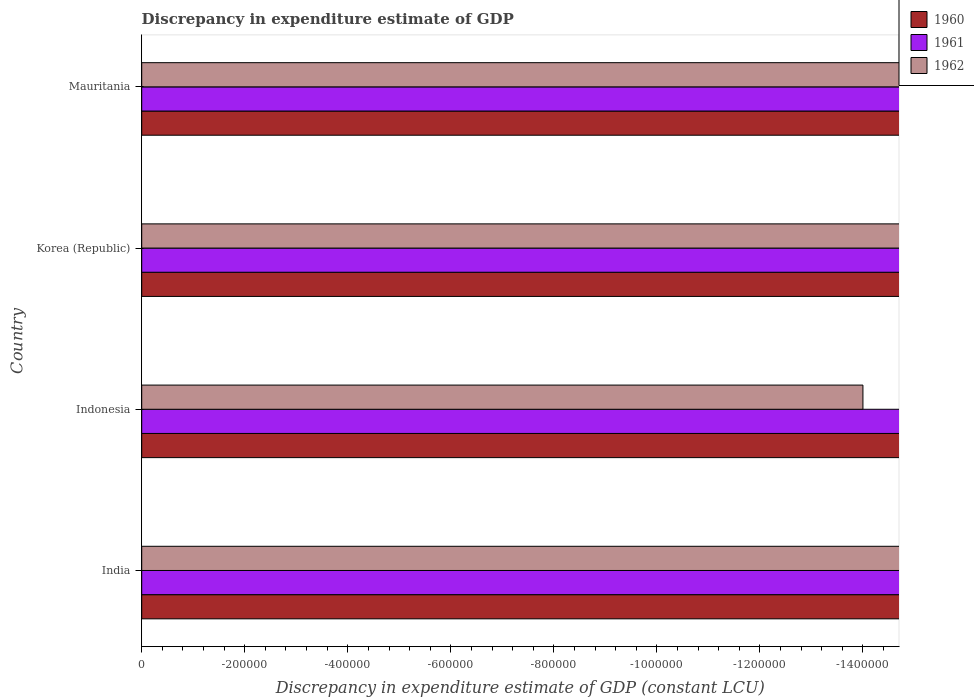Are the number of bars per tick equal to the number of legend labels?
Offer a very short reply. No. Are the number of bars on each tick of the Y-axis equal?
Provide a succinct answer. Yes. How many bars are there on the 3rd tick from the top?
Provide a succinct answer. 0. How many bars are there on the 3rd tick from the bottom?
Offer a terse response. 0. What is the label of the 4th group of bars from the top?
Provide a succinct answer. India. In how many cases, is the number of bars for a given country not equal to the number of legend labels?
Keep it short and to the point. 4. What is the discrepancy in expenditure estimate of GDP in 1960 in Indonesia?
Your answer should be compact. 0. What is the total discrepancy in expenditure estimate of GDP in 1961 in the graph?
Offer a terse response. 0. What is the difference between the discrepancy in expenditure estimate of GDP in 1961 in Korea (Republic) and the discrepancy in expenditure estimate of GDP in 1962 in Indonesia?
Your answer should be very brief. 0. What is the average discrepancy in expenditure estimate of GDP in 1960 per country?
Keep it short and to the point. 0. In how many countries, is the discrepancy in expenditure estimate of GDP in 1962 greater than -600000 LCU?
Provide a short and direct response. 0. In how many countries, is the discrepancy in expenditure estimate of GDP in 1962 greater than the average discrepancy in expenditure estimate of GDP in 1962 taken over all countries?
Ensure brevity in your answer.  0. Is it the case that in every country, the sum of the discrepancy in expenditure estimate of GDP in 1962 and discrepancy in expenditure estimate of GDP in 1961 is greater than the discrepancy in expenditure estimate of GDP in 1960?
Ensure brevity in your answer.  No. How many bars are there?
Your response must be concise. 0. How many countries are there in the graph?
Your answer should be very brief. 4. Does the graph contain grids?
Provide a short and direct response. No. Where does the legend appear in the graph?
Offer a terse response. Top right. How many legend labels are there?
Make the answer very short. 3. How are the legend labels stacked?
Keep it short and to the point. Vertical. What is the title of the graph?
Keep it short and to the point. Discrepancy in expenditure estimate of GDP. What is the label or title of the X-axis?
Provide a short and direct response. Discrepancy in expenditure estimate of GDP (constant LCU). What is the label or title of the Y-axis?
Your answer should be very brief. Country. What is the Discrepancy in expenditure estimate of GDP (constant LCU) in 1960 in India?
Ensure brevity in your answer.  0. What is the Discrepancy in expenditure estimate of GDP (constant LCU) in 1961 in India?
Offer a very short reply. 0. What is the Discrepancy in expenditure estimate of GDP (constant LCU) of 1962 in Indonesia?
Keep it short and to the point. 0. What is the Discrepancy in expenditure estimate of GDP (constant LCU) in 1960 in Korea (Republic)?
Provide a succinct answer. 0. What is the Discrepancy in expenditure estimate of GDP (constant LCU) of 1961 in Korea (Republic)?
Your answer should be compact. 0. What is the Discrepancy in expenditure estimate of GDP (constant LCU) of 1961 in Mauritania?
Your response must be concise. 0. What is the total Discrepancy in expenditure estimate of GDP (constant LCU) of 1960 in the graph?
Your answer should be compact. 0. What is the total Discrepancy in expenditure estimate of GDP (constant LCU) in 1961 in the graph?
Make the answer very short. 0. What is the total Discrepancy in expenditure estimate of GDP (constant LCU) of 1962 in the graph?
Make the answer very short. 0. What is the average Discrepancy in expenditure estimate of GDP (constant LCU) in 1960 per country?
Your answer should be compact. 0. What is the average Discrepancy in expenditure estimate of GDP (constant LCU) in 1961 per country?
Make the answer very short. 0. 